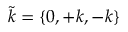Convert formula to latex. <formula><loc_0><loc_0><loc_500><loc_500>\tilde { k } = \{ 0 , + k , - k \}</formula> 